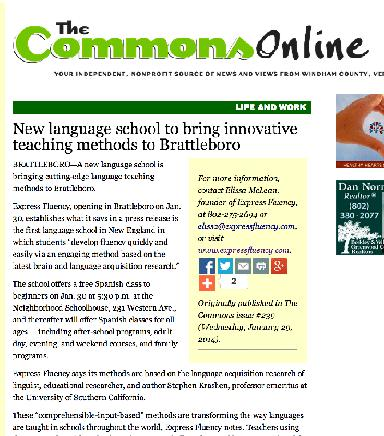How does the school plan to incorporate Krashen's theories into its curriculum? The school intends to integrate Krashen's input hypothesis into its curriculum by focusing on providing comprehensible input that is slightly beyond the current level of the learner, allowing students to enhance their language skills through natural, meaningful use of language. 